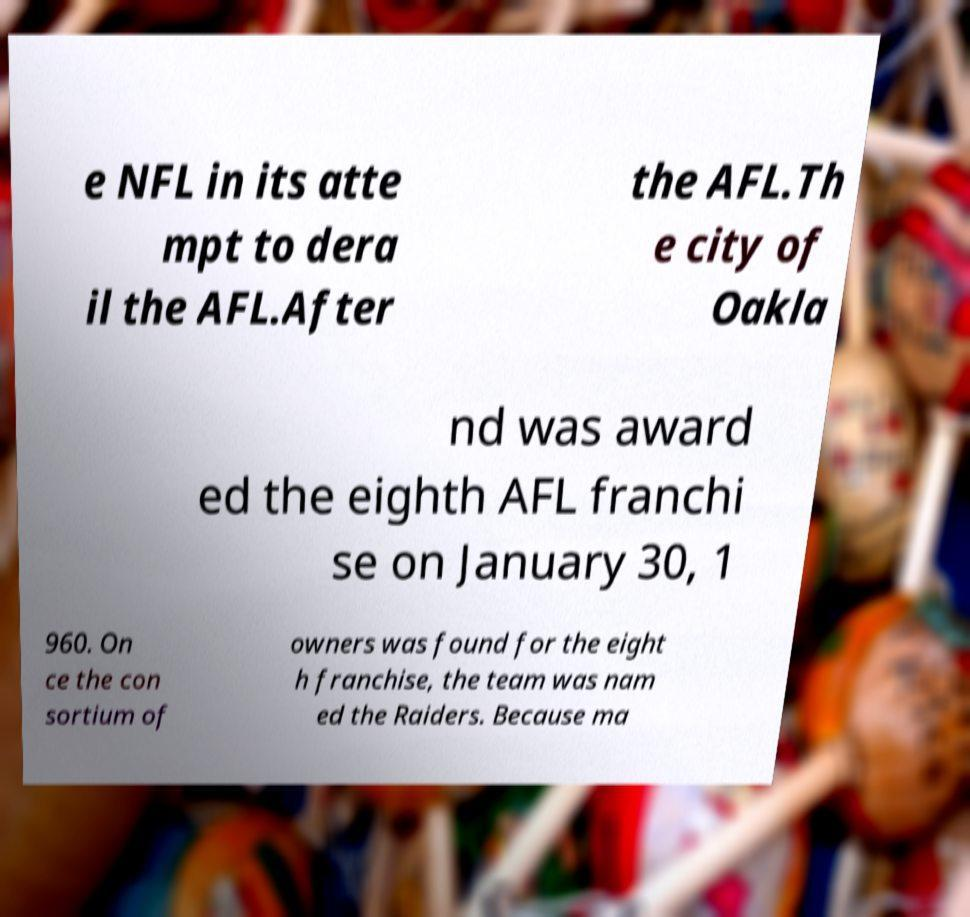There's text embedded in this image that I need extracted. Can you transcribe it verbatim? e NFL in its atte mpt to dera il the AFL.After the AFL.Th e city of Oakla nd was award ed the eighth AFL franchi se on January 30, 1 960. On ce the con sortium of owners was found for the eight h franchise, the team was nam ed the Raiders. Because ma 